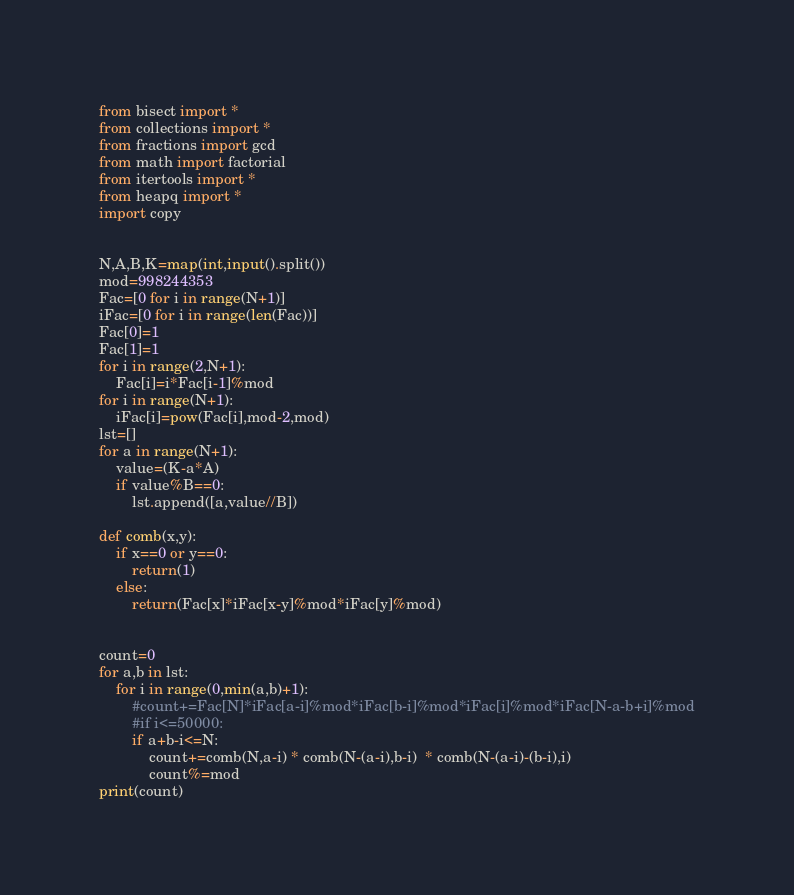<code> <loc_0><loc_0><loc_500><loc_500><_Python_>from bisect import *
from collections import *
from fractions import gcd
from math import factorial
from itertools import *
from heapq import *
import copy


N,A,B,K=map(int,input().split())
mod=998244353
Fac=[0 for i in range(N+1)]
iFac=[0 for i in range(len(Fac))]
Fac[0]=1
Fac[1]=1
for i in range(2,N+1):
    Fac[i]=i*Fac[i-1]%mod
for i in range(N+1):
    iFac[i]=pow(Fac[i],mod-2,mod)
lst=[]
for a in range(N+1):
    value=(K-a*A)
    if value%B==0:
        lst.append([a,value//B])

def comb(x,y):
    if x==0 or y==0:
        return(1)
    else:
        return(Fac[x]*iFac[x-y]%mod*iFac[y]%mod)


count=0
for a,b in lst:
    for i in range(0,min(a,b)+1):
        #count+=Fac[N]*iFac[a-i]%mod*iFac[b-i]%mod*iFac[i]%mod*iFac[N-a-b+i]%mod
        #if i<=50000:
        if a+b-i<=N:
            count+=comb(N,a-i) * comb(N-(a-i),b-i)  * comb(N-(a-i)-(b-i),i)
            count%=mod
print(count)
</code> 